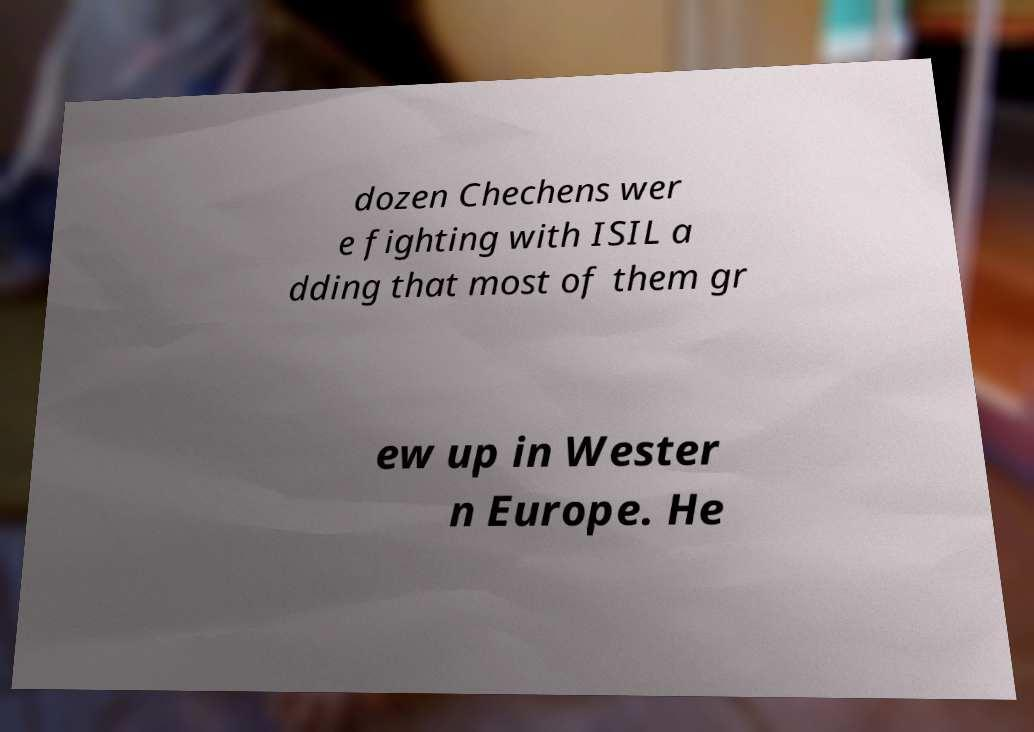Could you assist in decoding the text presented in this image and type it out clearly? dozen Chechens wer e fighting with ISIL a dding that most of them gr ew up in Wester n Europe. He 